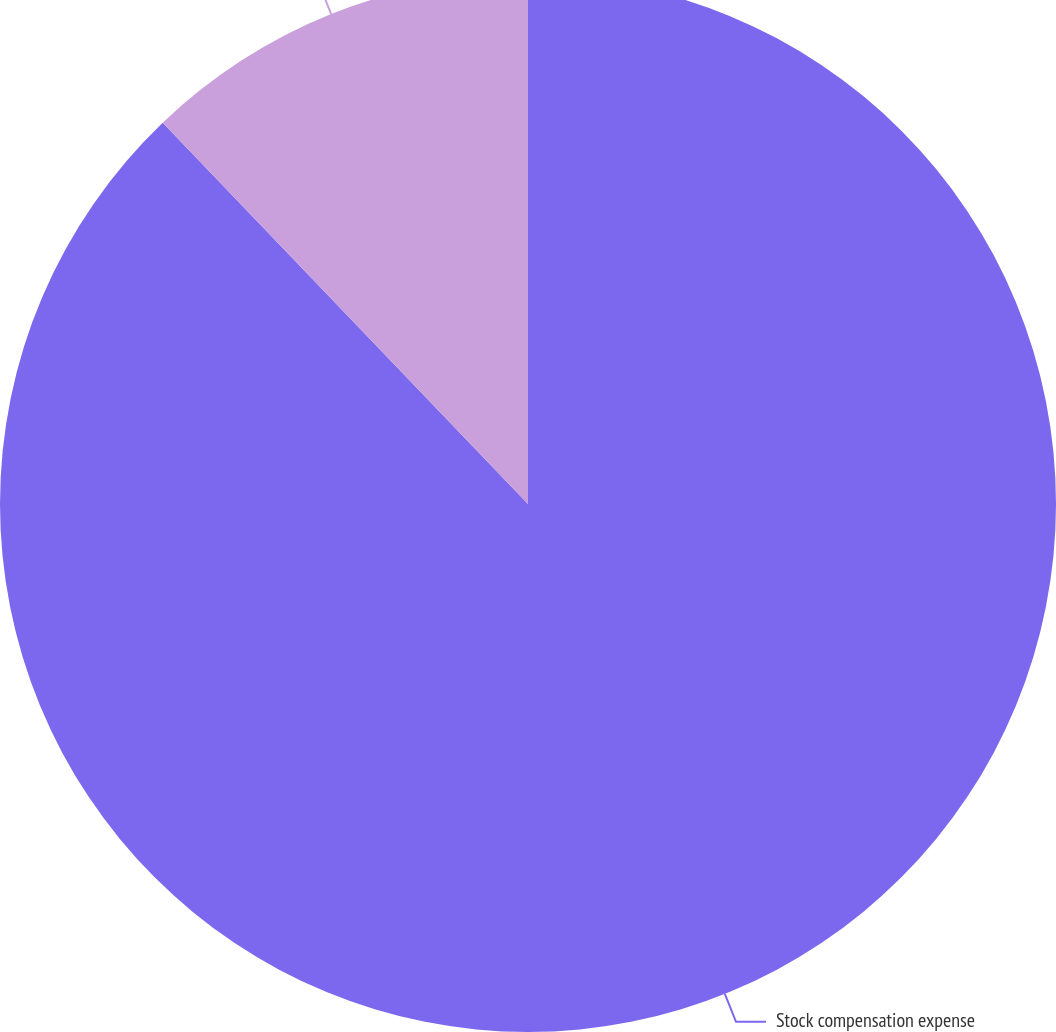<chart> <loc_0><loc_0><loc_500><loc_500><pie_chart><fcel>Stock compensation expense<fcel>Recognized tax benefit<nl><fcel>87.84%<fcel>12.16%<nl></chart> 